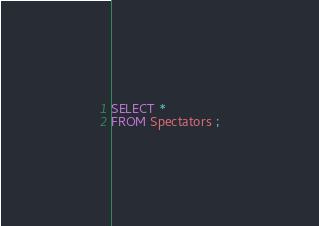Convert code to text. <code><loc_0><loc_0><loc_500><loc_500><_SQL_>SELECT *
FROM Spectators ;</code> 